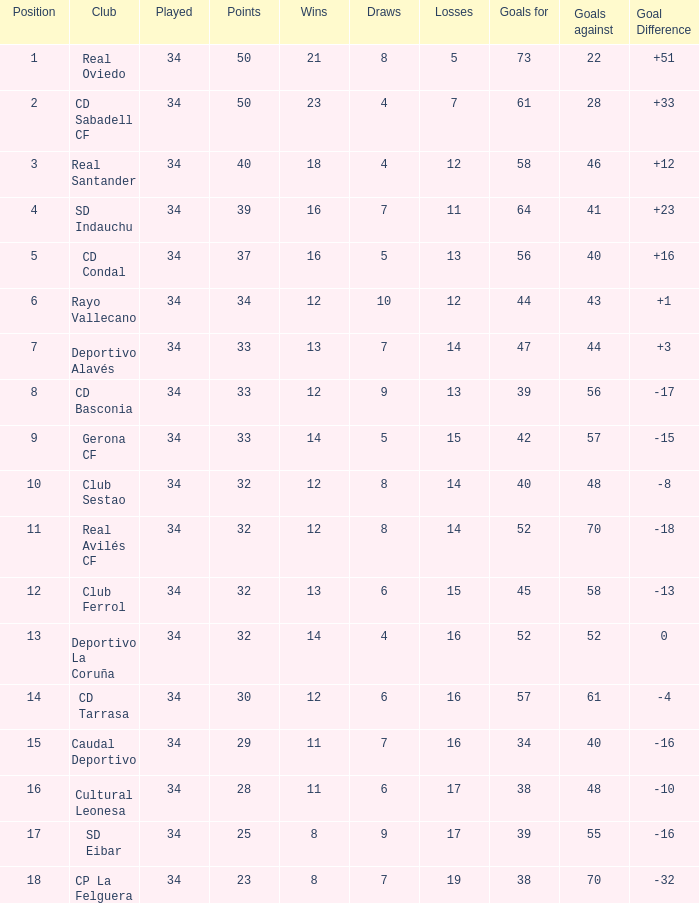In how many instances have teams conceded goals when they played over 34 matches? 0.0. 